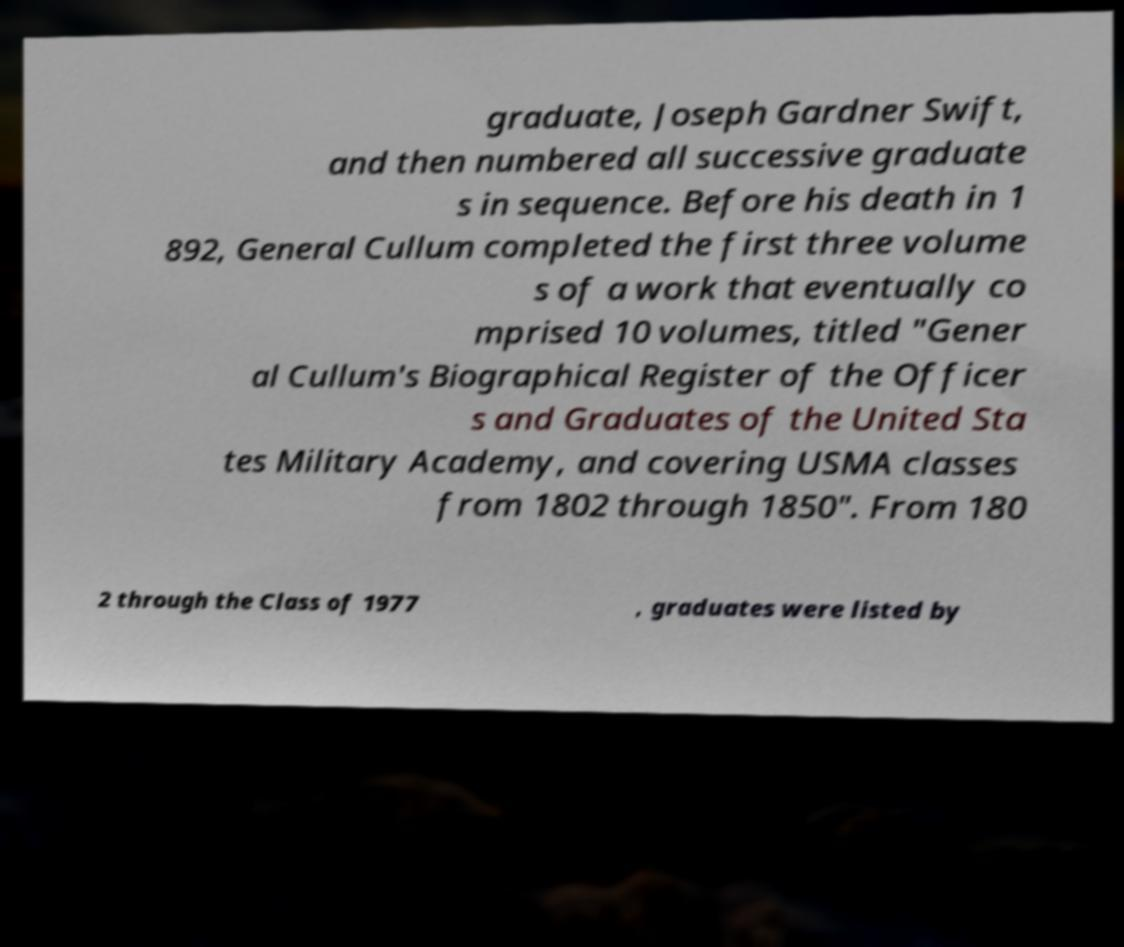Can you accurately transcribe the text from the provided image for me? graduate, Joseph Gardner Swift, and then numbered all successive graduate s in sequence. Before his death in 1 892, General Cullum completed the first three volume s of a work that eventually co mprised 10 volumes, titled "Gener al Cullum's Biographical Register of the Officer s and Graduates of the United Sta tes Military Academy, and covering USMA classes from 1802 through 1850". From 180 2 through the Class of 1977 , graduates were listed by 